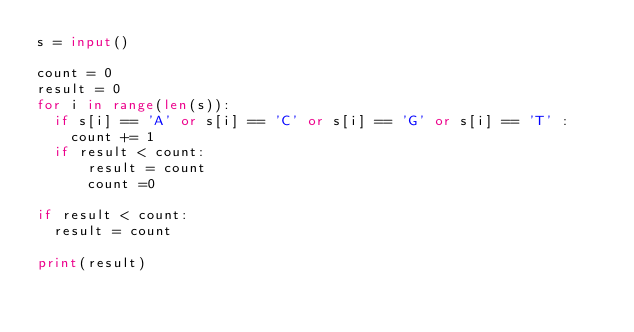Convert code to text. <code><loc_0><loc_0><loc_500><loc_500><_Python_>s = input()

count = 0
result = 0
for i in range(len(s)):
  if s[i] == 'A' or s[i] == 'C' or s[i] == 'G' or s[i] == 'T' :
    count += 1
  if result < count:
      result = count
      count =0

if result < count:
  result = count

print(result)
</code> 